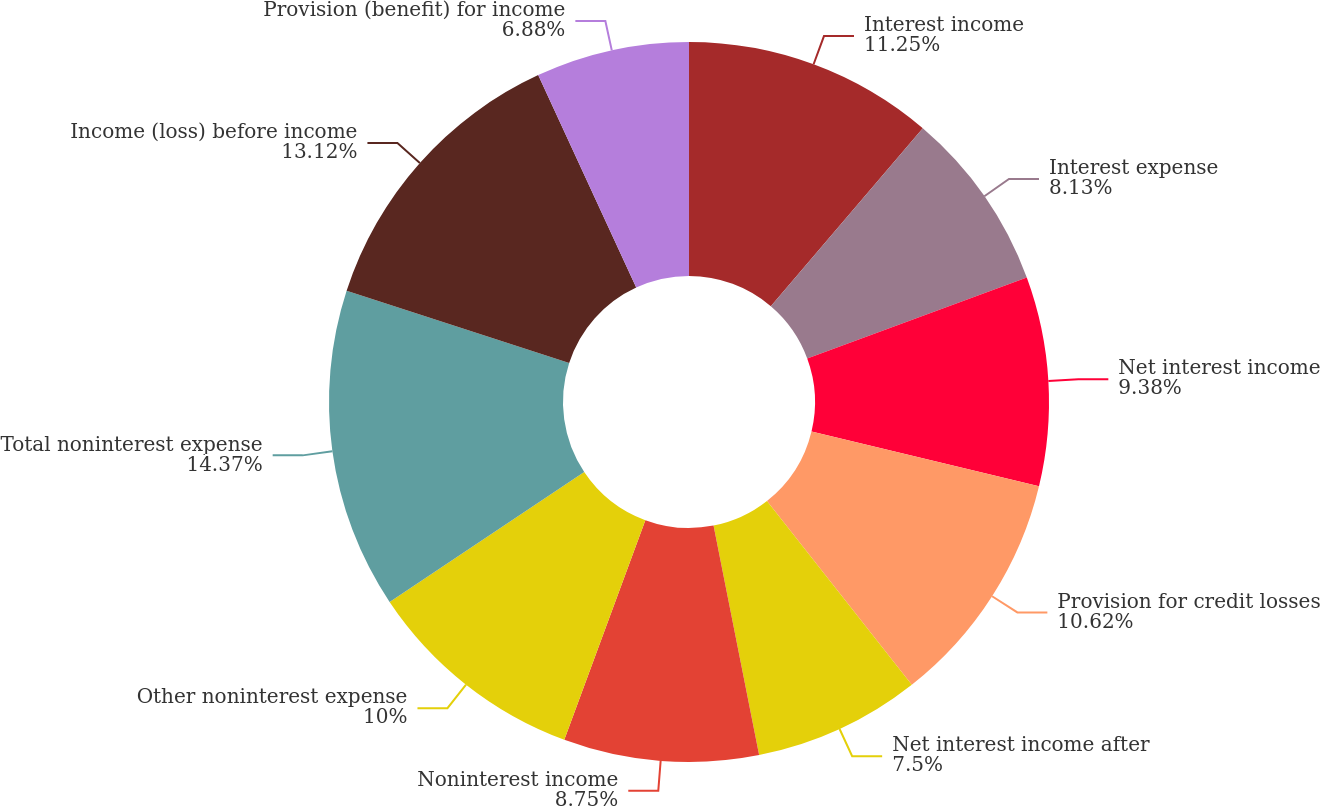<chart> <loc_0><loc_0><loc_500><loc_500><pie_chart><fcel>Interest income<fcel>Interest expense<fcel>Net interest income<fcel>Provision for credit losses<fcel>Net interest income after<fcel>Noninterest income<fcel>Other noninterest expense<fcel>Total noninterest expense<fcel>Income (loss) before income<fcel>Provision (benefit) for income<nl><fcel>11.25%<fcel>8.13%<fcel>9.38%<fcel>10.62%<fcel>7.5%<fcel>8.75%<fcel>10.0%<fcel>14.37%<fcel>13.12%<fcel>6.88%<nl></chart> 